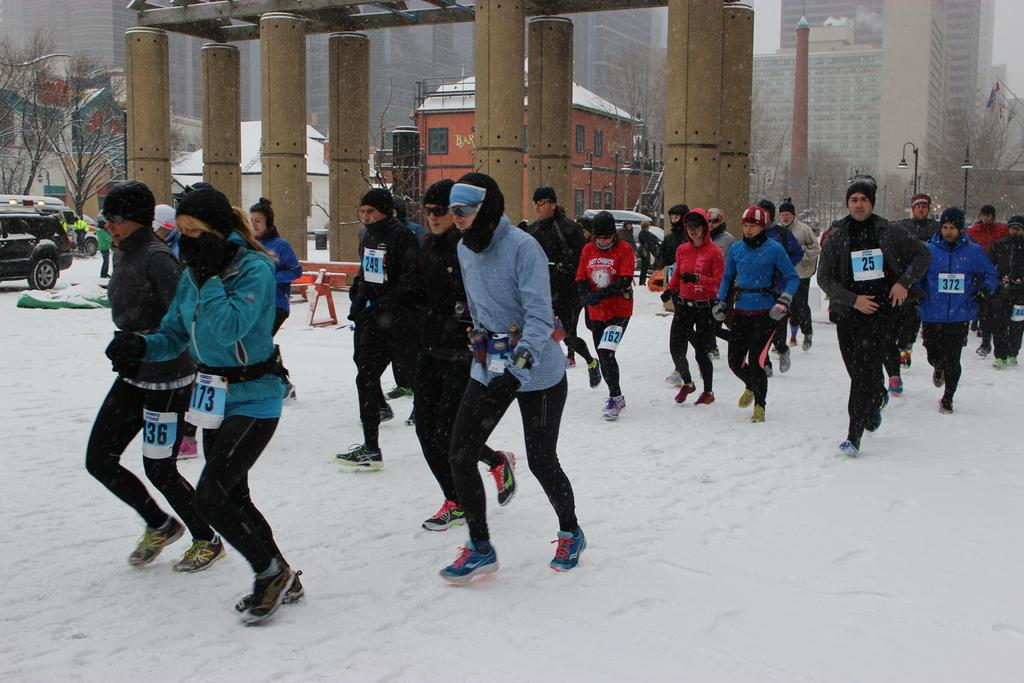What are the people in the image doing? The people in the image are running on the snow. What can be seen in the background of the image? In the background of the image, there are pillars, trees, a house, buildings, and the sky. How many types of structures are visible in the background? There are three types of structures visible in the background: pillars, a house, and buildings. What type of grain is being harvested in the image? There is no grain present in the image; it features people running on snow with various structures and natural elements in the background. 